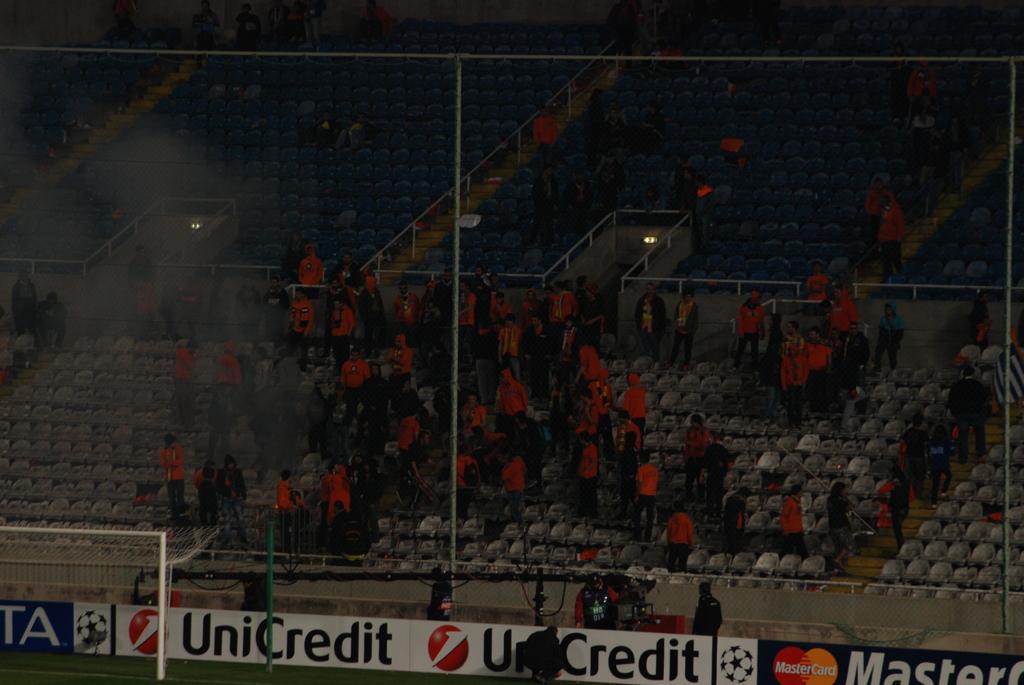What credit service is advertised on this soccer wall?
Provide a succinct answer. Unicredit. What credit card brand is shown?
Offer a terse response. Unicredit. 